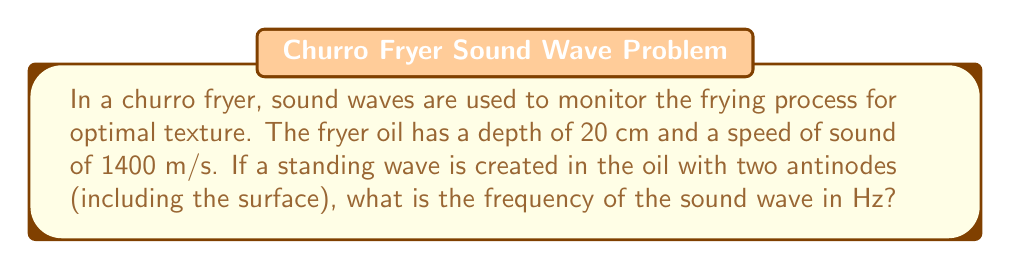Solve this math problem. To solve this problem, we'll follow these steps:

1) In a standing wave, the distance between two consecutive antinodes is half a wavelength. Since we have two antinodes in 20 cm of oil, this distance represents half a wavelength.

2) Therefore, the wavelength λ is:
   $$\lambda = 2 * 20\text{ cm} = 40\text{ cm} = 0.4\text{ m}$$

3) We know the speed of sound in the oil is 1400 m/s. We can use the wave equation to find the frequency:
   $$v = f\lambda$$
   where v is the speed of sound, f is the frequency, and λ is the wavelength.

4) Rearranging the equation to solve for f:
   $$f = \frac{v}{\lambda}$$

5) Substituting our values:
   $$f = \frac{1400\text{ m/s}}{0.4\text{ m}}$$

6) Calculating:
   $$f = 3500\text{ Hz}$$

Thus, the frequency of the sound wave is 3500 Hz.
Answer: 3500 Hz 